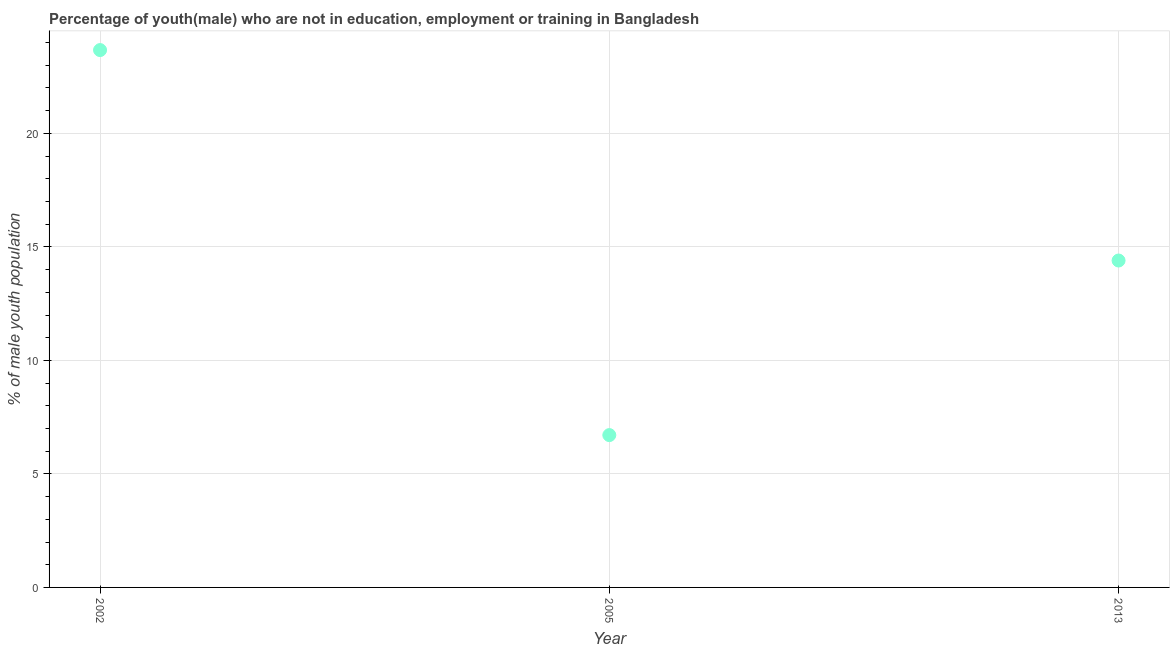What is the unemployed male youth population in 2005?
Ensure brevity in your answer.  6.71. Across all years, what is the maximum unemployed male youth population?
Offer a very short reply. 23.67. Across all years, what is the minimum unemployed male youth population?
Give a very brief answer. 6.71. In which year was the unemployed male youth population minimum?
Ensure brevity in your answer.  2005. What is the sum of the unemployed male youth population?
Your answer should be compact. 44.78. What is the difference between the unemployed male youth population in 2002 and 2005?
Provide a succinct answer. 16.96. What is the average unemployed male youth population per year?
Your answer should be compact. 14.93. What is the median unemployed male youth population?
Offer a terse response. 14.4. In how many years, is the unemployed male youth population greater than 14 %?
Your response must be concise. 2. What is the ratio of the unemployed male youth population in 2005 to that in 2013?
Your response must be concise. 0.47. What is the difference between the highest and the second highest unemployed male youth population?
Provide a short and direct response. 9.27. Is the sum of the unemployed male youth population in 2005 and 2013 greater than the maximum unemployed male youth population across all years?
Ensure brevity in your answer.  No. What is the difference between the highest and the lowest unemployed male youth population?
Offer a very short reply. 16.96. What is the difference between two consecutive major ticks on the Y-axis?
Give a very brief answer. 5. Are the values on the major ticks of Y-axis written in scientific E-notation?
Provide a short and direct response. No. Does the graph contain any zero values?
Give a very brief answer. No. What is the title of the graph?
Provide a short and direct response. Percentage of youth(male) who are not in education, employment or training in Bangladesh. What is the label or title of the X-axis?
Your answer should be compact. Year. What is the label or title of the Y-axis?
Provide a succinct answer. % of male youth population. What is the % of male youth population in 2002?
Give a very brief answer. 23.67. What is the % of male youth population in 2005?
Ensure brevity in your answer.  6.71. What is the % of male youth population in 2013?
Keep it short and to the point. 14.4. What is the difference between the % of male youth population in 2002 and 2005?
Provide a short and direct response. 16.96. What is the difference between the % of male youth population in 2002 and 2013?
Your answer should be compact. 9.27. What is the difference between the % of male youth population in 2005 and 2013?
Ensure brevity in your answer.  -7.69. What is the ratio of the % of male youth population in 2002 to that in 2005?
Offer a terse response. 3.53. What is the ratio of the % of male youth population in 2002 to that in 2013?
Offer a terse response. 1.64. What is the ratio of the % of male youth population in 2005 to that in 2013?
Keep it short and to the point. 0.47. 